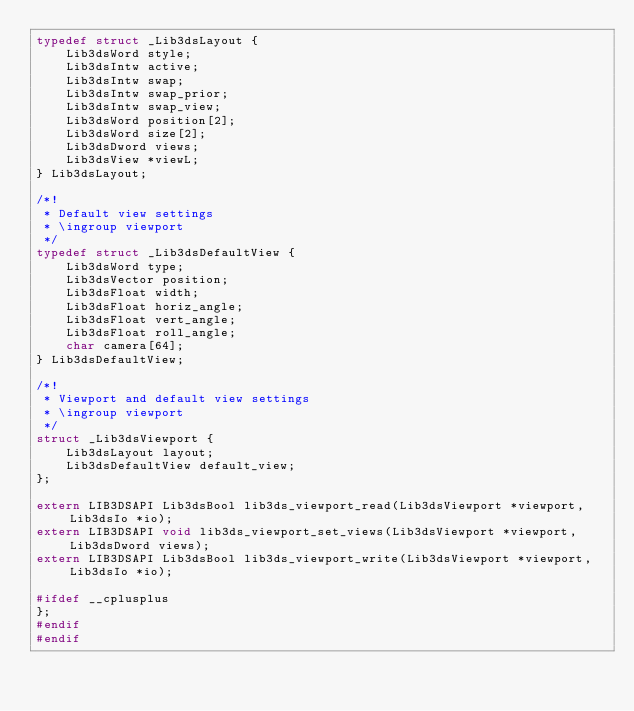<code> <loc_0><loc_0><loc_500><loc_500><_C_>typedef struct _Lib3dsLayout {
    Lib3dsWord style;
    Lib3dsIntw active;
    Lib3dsIntw swap;
    Lib3dsIntw swap_prior;
    Lib3dsIntw swap_view;
    Lib3dsWord position[2];
    Lib3dsWord size[2];
    Lib3dsDword views;
    Lib3dsView *viewL;
} Lib3dsLayout;

/*!
 * Default view settings
 * \ingroup viewport
 */
typedef struct _Lib3dsDefaultView {
    Lib3dsWord type;
    Lib3dsVector position;
    Lib3dsFloat width;
    Lib3dsFloat horiz_angle;
    Lib3dsFloat vert_angle;
    Lib3dsFloat roll_angle;
    char camera[64];
} Lib3dsDefaultView;

/*!
 * Viewport and default view settings
 * \ingroup viewport
 */
struct _Lib3dsViewport {
    Lib3dsLayout layout;
    Lib3dsDefaultView default_view;
};

extern LIB3DSAPI Lib3dsBool lib3ds_viewport_read(Lib3dsViewport *viewport, Lib3dsIo *io);
extern LIB3DSAPI void lib3ds_viewport_set_views(Lib3dsViewport *viewport, Lib3dsDword views);
extern LIB3DSAPI Lib3dsBool lib3ds_viewport_write(Lib3dsViewport *viewport, Lib3dsIo *io);

#ifdef __cplusplus
};
#endif
#endif




</code> 